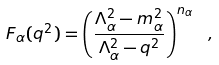Convert formula to latex. <formula><loc_0><loc_0><loc_500><loc_500>F _ { \alpha } ( q ^ { 2 } ) = \left ( \frac { \Lambda _ { \alpha } ^ { 2 } - m _ { \alpha } ^ { 2 } } { \Lambda _ { \alpha } ^ { 2 } - q ^ { 2 } } \right ) ^ { n _ { \alpha } } \ ,</formula> 